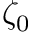<formula> <loc_0><loc_0><loc_500><loc_500>\zeta _ { 0 }</formula> 